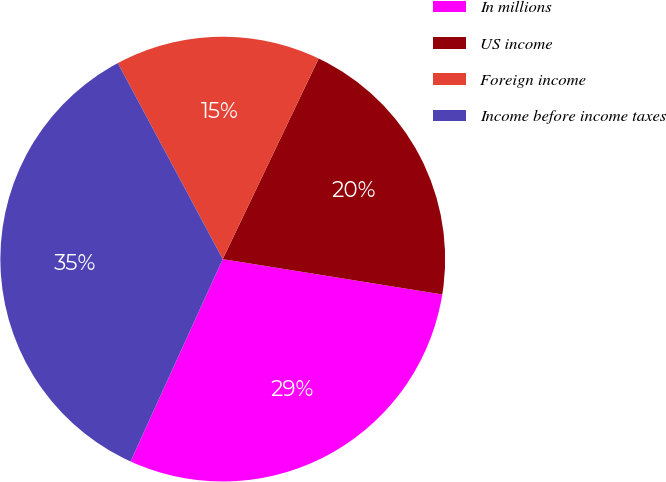Convert chart to OTSL. <chart><loc_0><loc_0><loc_500><loc_500><pie_chart><fcel>In millions<fcel>US income<fcel>Foreign income<fcel>Income before income taxes<nl><fcel>29.26%<fcel>20.44%<fcel>14.92%<fcel>35.37%<nl></chart> 